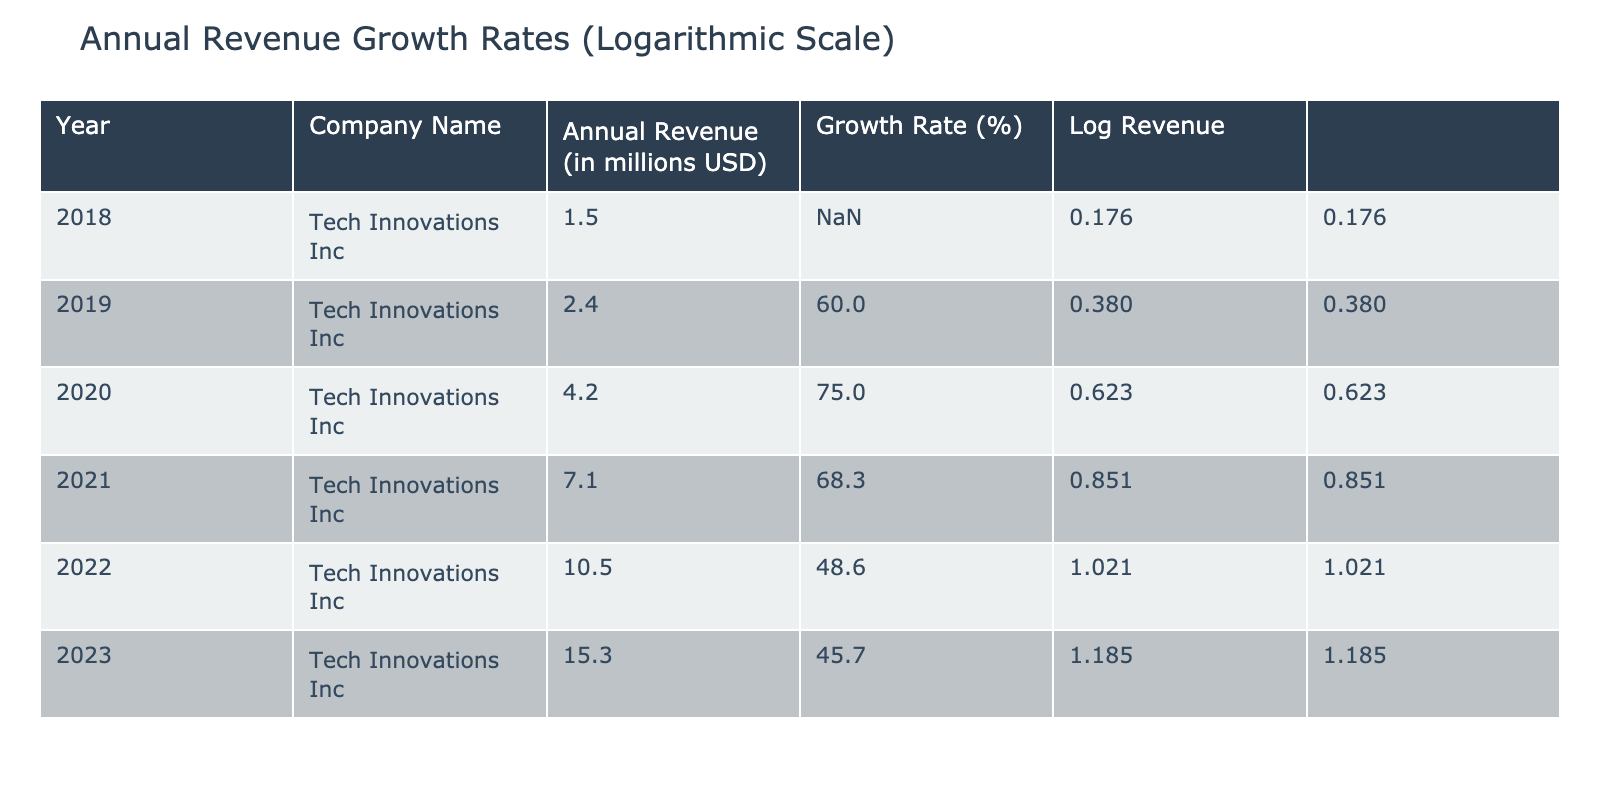What was the annual revenue of Tech Innovations Inc in 2020? The table shows the annual revenue for each year. In 2020, the annual revenue listed is 4.2 million USD.
Answer: 4.2 million USD What is the growth rate for Tech Innovations Inc in 2019? According to the table, the growth rate for 2019 is listed as 60.0%.
Answer: 60.0% What was the total annual revenue from 2018 to 2023? To get the total annual revenue, we sum up the annual revenues for each year: 1.5 + 2.4 + 4.2 + 7.1 + 10.5 + 15.3 = 41.0 million USD.
Answer: 41.0 million USD Was the growth rate in 2022 higher than in 2021? The table shows that the growth rate in 2022 is 48.6% and in 2021 is 68.3%. Since 48.6% is less than 68.3%, the statement is false.
Answer: No What is the average growth rate from 2019 to 2023? The growth rates from 2019 to 2023 are 60.0, 75.0, 68.3, 48.6, and 45.7. Adding these gives a total of 297.6, and dividing by 5 (the number of years) results in an average growth rate of 59.52%.
Answer: 59.52% What was the highest annual revenue and in which year was it achieved? Reviewing the table, the highest annual revenue is 15.3 million USD, achieved in 2023.
Answer: 15.3 million USD in 2023 Is there any year where the growth rate was over 70%? The growth rates shown in the table indicate that in 2020, the growth rate was 75.0%, which is greater than 70%. Therefore, there is indeed a year where the growth rate exceeds this amount.
Answer: Yes What was the percentage increase in revenue from 2021 to 2022? To find the percentage increase, we take the revenue for 2022 (10.5 million USD) minus the revenue for 2021 (7.1 million USD), which equals 3.4 million USD. We then divide by the revenue for 2021 (7.1) and multiply by 100 to express it as a percentage: (3.4 / 7.1) * 100 ≈ 47.89%.
Answer: 47.89% Did Tech Innovations Inc experience growth every year from 2018 to 2023? By examining each year, we see that the growth rates for all years are positive (even if the growth rate decreased), confirming that there was growth every year.
Answer: Yes 